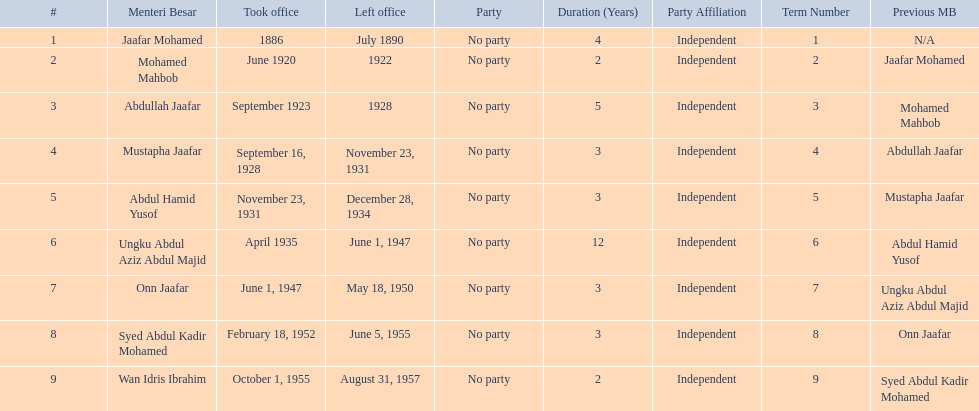Who are all of the menteri besars? Jaafar Mohamed, Mohamed Mahbob, Abdullah Jaafar, Mustapha Jaafar, Abdul Hamid Yusof, Ungku Abdul Aziz Abdul Majid, Onn Jaafar, Syed Abdul Kadir Mohamed, Wan Idris Ibrahim. When did each take office? 1886, June 1920, September 1923, September 16, 1928, November 23, 1931, April 1935, June 1, 1947, February 18, 1952, October 1, 1955. When did they leave? July 1890, 1922, 1928, November 23, 1931, December 28, 1934, June 1, 1947, May 18, 1950, June 5, 1955, August 31, 1957. And which spent the most time in office? Ungku Abdul Aziz Abdul Majid. 